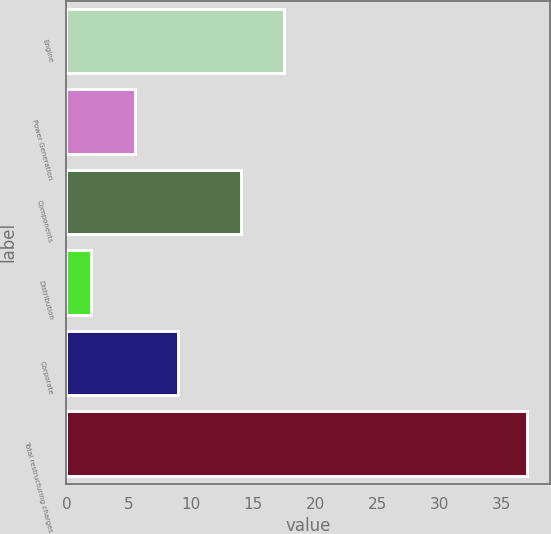Convert chart to OTSL. <chart><loc_0><loc_0><loc_500><loc_500><bar_chart><fcel>Engine<fcel>Power Generation<fcel>Components<fcel>Distribution<fcel>Corporate<fcel>Total restructuring charges<nl><fcel>17.5<fcel>5.5<fcel>14<fcel>2<fcel>9<fcel>37<nl></chart> 